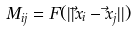Convert formula to latex. <formula><loc_0><loc_0><loc_500><loc_500>M _ { i j } = F ( | | \vec { x } _ { i } - \vec { x } _ { j } | | )</formula> 